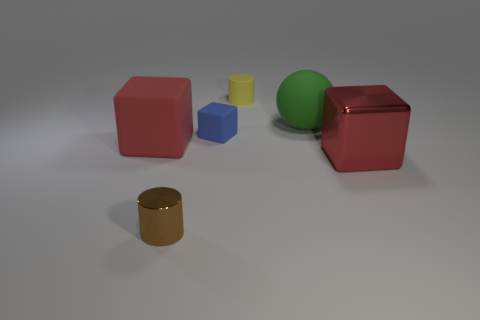Add 1 tiny gray things. How many objects exist? 7 Subtract all cylinders. How many objects are left? 4 Add 1 brown cylinders. How many brown cylinders exist? 2 Subtract 0 yellow blocks. How many objects are left? 6 Subtract all small blue matte things. Subtract all blue matte blocks. How many objects are left? 4 Add 6 large red things. How many large red things are left? 8 